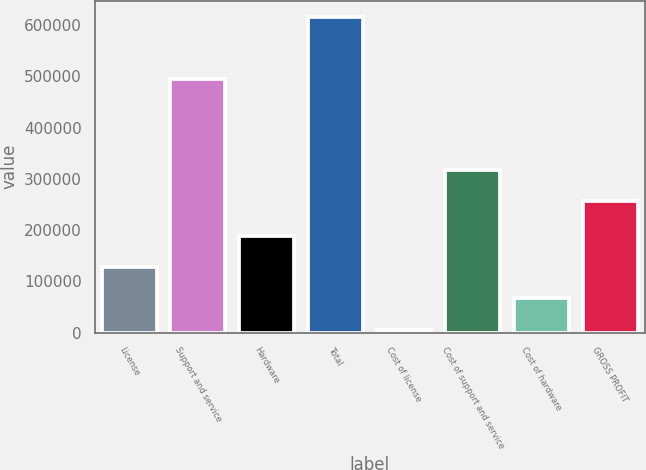Convert chart. <chart><loc_0><loc_0><loc_500><loc_500><bar_chart><fcel>License<fcel>Support and service<fcel>Hardware<fcel>Total<fcel>Cost of license<fcel>Cost of support and service<fcel>Cost of hardware<fcel>GROSS PROFIT<nl><fcel>127579<fcel>495687<fcel>188680<fcel>616390<fcel>5376<fcel>316971<fcel>66477.4<fcel>255870<nl></chart> 